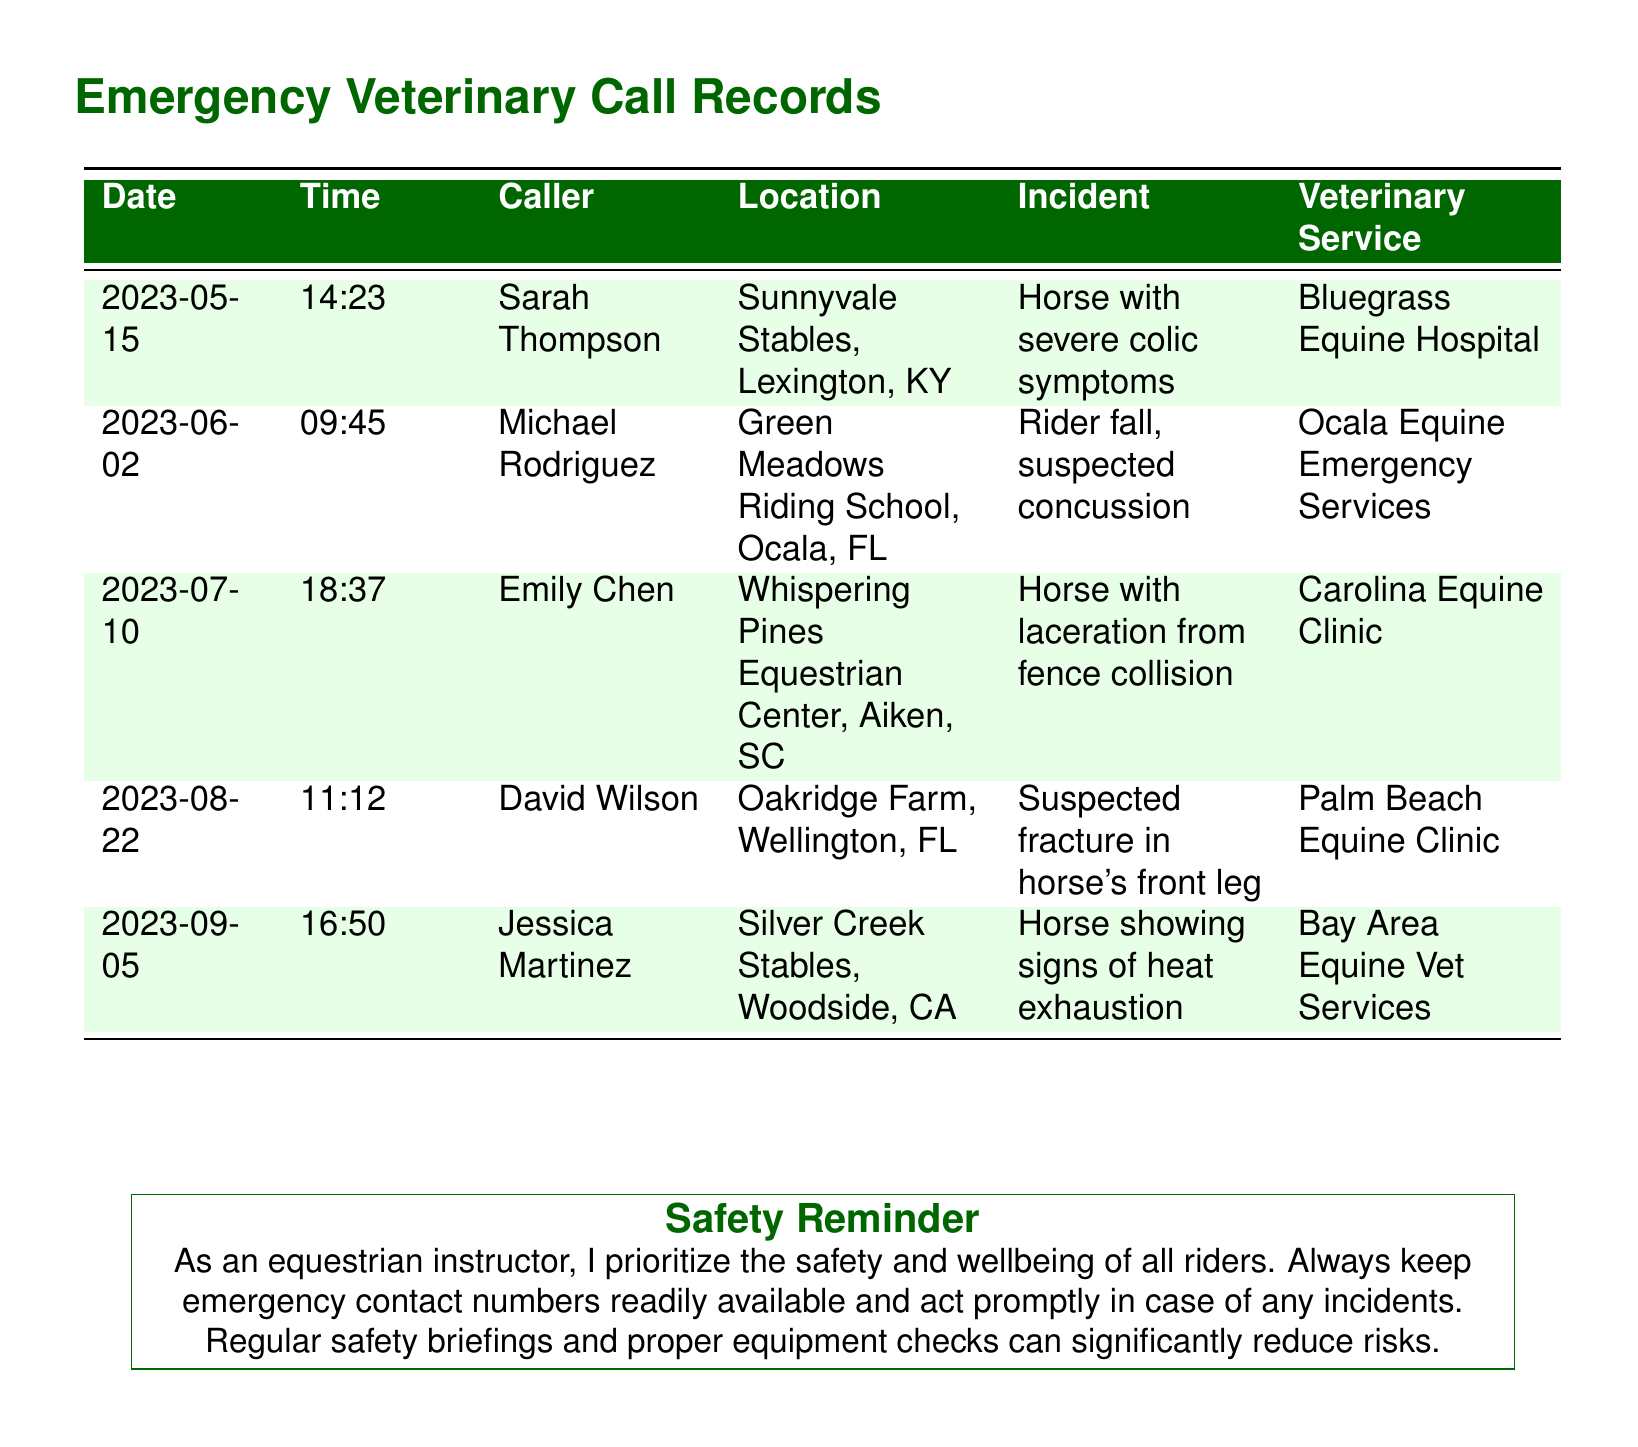What is the date of the incident involving severe colic symptoms? The date listed for the severe colic incident is 2023-05-15.
Answer: 2023-05-15 Who called for veterinary services regarding a suspected concussion? The caller for the incident involving a suspected concussion is Michael Rodriguez.
Answer: Michael Rodriguez What was the incident reported at Oakridge Farm? The incident reported at Oakridge Farm was a suspected fracture in the horse's front leg.
Answer: Suspected fracture in horse's front leg Which veterinary service was contacted for the horse showing signs of heat exhaustion? The veterinary service contacted for the heat exhaustion incident is Bay Area Equine Vet Services.
Answer: Bay Area Equine Vet Services How many incidents were reported in total? Five incidents are listed in the document.
Answer: 5 What was the location of the call regarding a horse with a laceration? The location mentioned for the horse with a laceration is Whispering Pines Equestrian Center, Aiken, SC.
Answer: Whispering Pines Equestrian Center, Aiken, SC Which caller's incident took place last in the records? The last incident recorded is by Jessica Martinez.
Answer: Jessica Martinez What time was the call made for the horse with severe colic symptoms? The time of the call for the severe colic symptoms is 14:23.
Answer: 14:23 